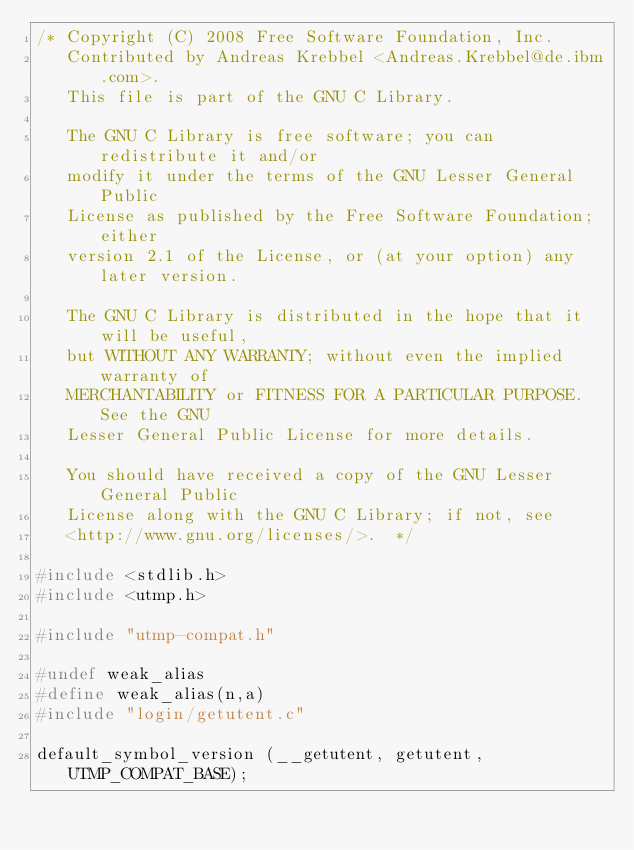<code> <loc_0><loc_0><loc_500><loc_500><_C_>/* Copyright (C) 2008 Free Software Foundation, Inc.
   Contributed by Andreas Krebbel <Andreas.Krebbel@de.ibm.com>.
   This file is part of the GNU C Library.

   The GNU C Library is free software; you can redistribute it and/or
   modify it under the terms of the GNU Lesser General Public
   License as published by the Free Software Foundation; either
   version 2.1 of the License, or (at your option) any later version.

   The GNU C Library is distributed in the hope that it will be useful,
   but WITHOUT ANY WARRANTY; without even the implied warranty of
   MERCHANTABILITY or FITNESS FOR A PARTICULAR PURPOSE.  See the GNU
   Lesser General Public License for more details.

   You should have received a copy of the GNU Lesser General Public
   License along with the GNU C Library; if not, see
   <http://www.gnu.org/licenses/>.  */

#include <stdlib.h>
#include <utmp.h>

#include "utmp-compat.h"

#undef weak_alias
#define weak_alias(n,a)
#include "login/getutent.c"

default_symbol_version (__getutent, getutent, UTMP_COMPAT_BASE);
</code> 